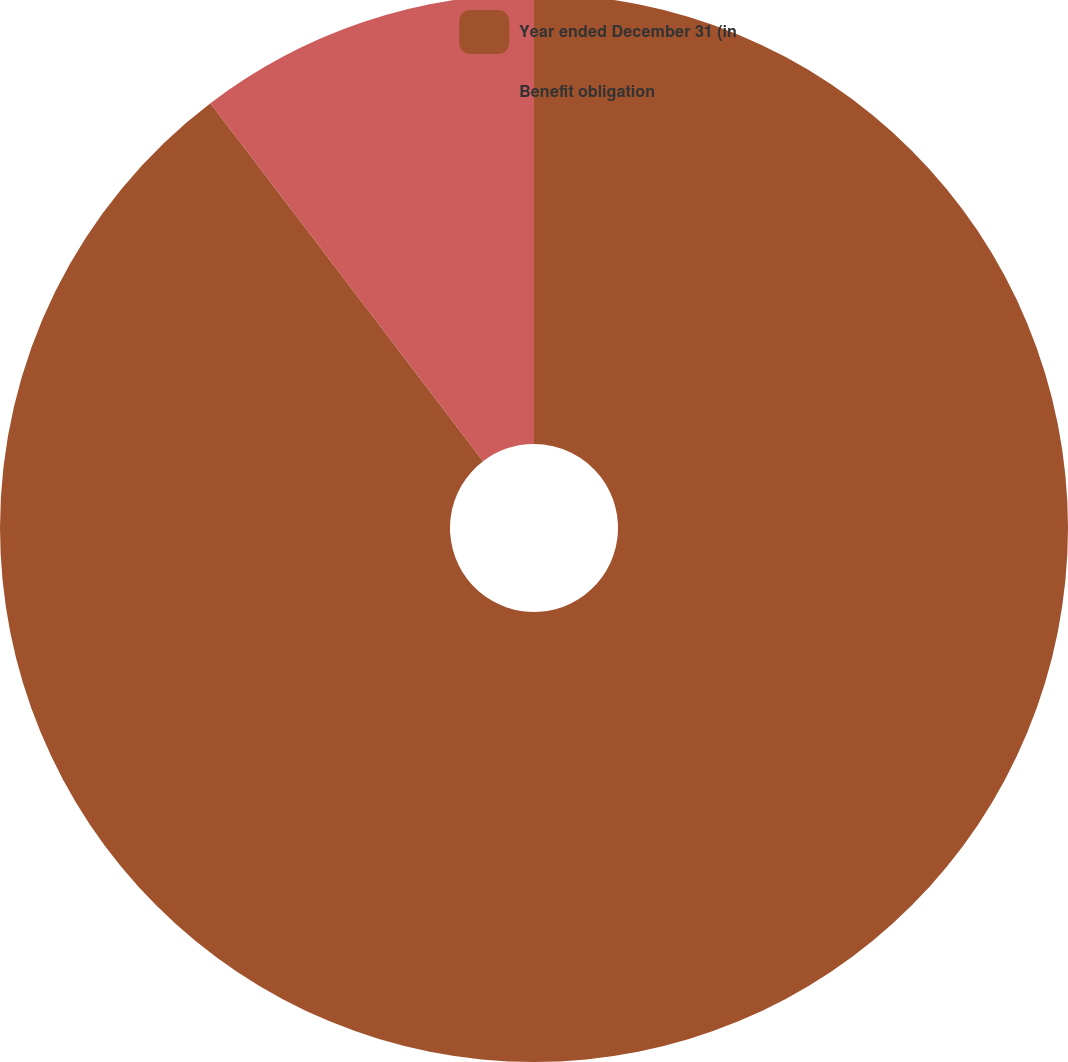<chart> <loc_0><loc_0><loc_500><loc_500><pie_chart><fcel>Year ended December 31 (in<fcel>Benefit obligation<nl><fcel>89.64%<fcel>10.36%<nl></chart> 